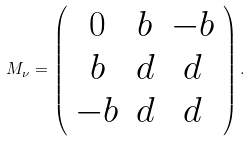Convert formula to latex. <formula><loc_0><loc_0><loc_500><loc_500>M _ { \nu } = \left ( \begin{array} { c c c } 0 & b & - b \\ b & d & d \\ - b & d & d \\ \end{array} \right ) .</formula> 